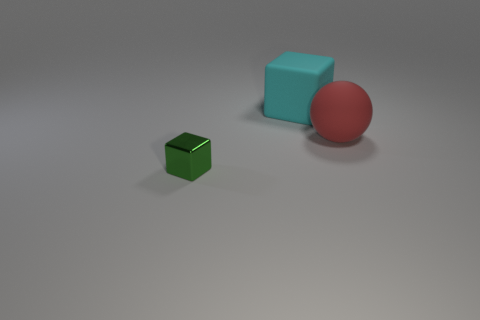Add 2 green cubes. How many objects exist? 5 Subtract all spheres. How many objects are left? 2 Add 1 red rubber things. How many red rubber things are left? 2 Add 2 cyan metallic cubes. How many cyan metallic cubes exist? 2 Subtract 0 blue spheres. How many objects are left? 3 Subtract 1 spheres. How many spheres are left? 0 Subtract all green cubes. Subtract all green balls. How many cubes are left? 1 Subtract all cyan balls. How many cyan blocks are left? 1 Subtract all metal cubes. Subtract all matte cubes. How many objects are left? 1 